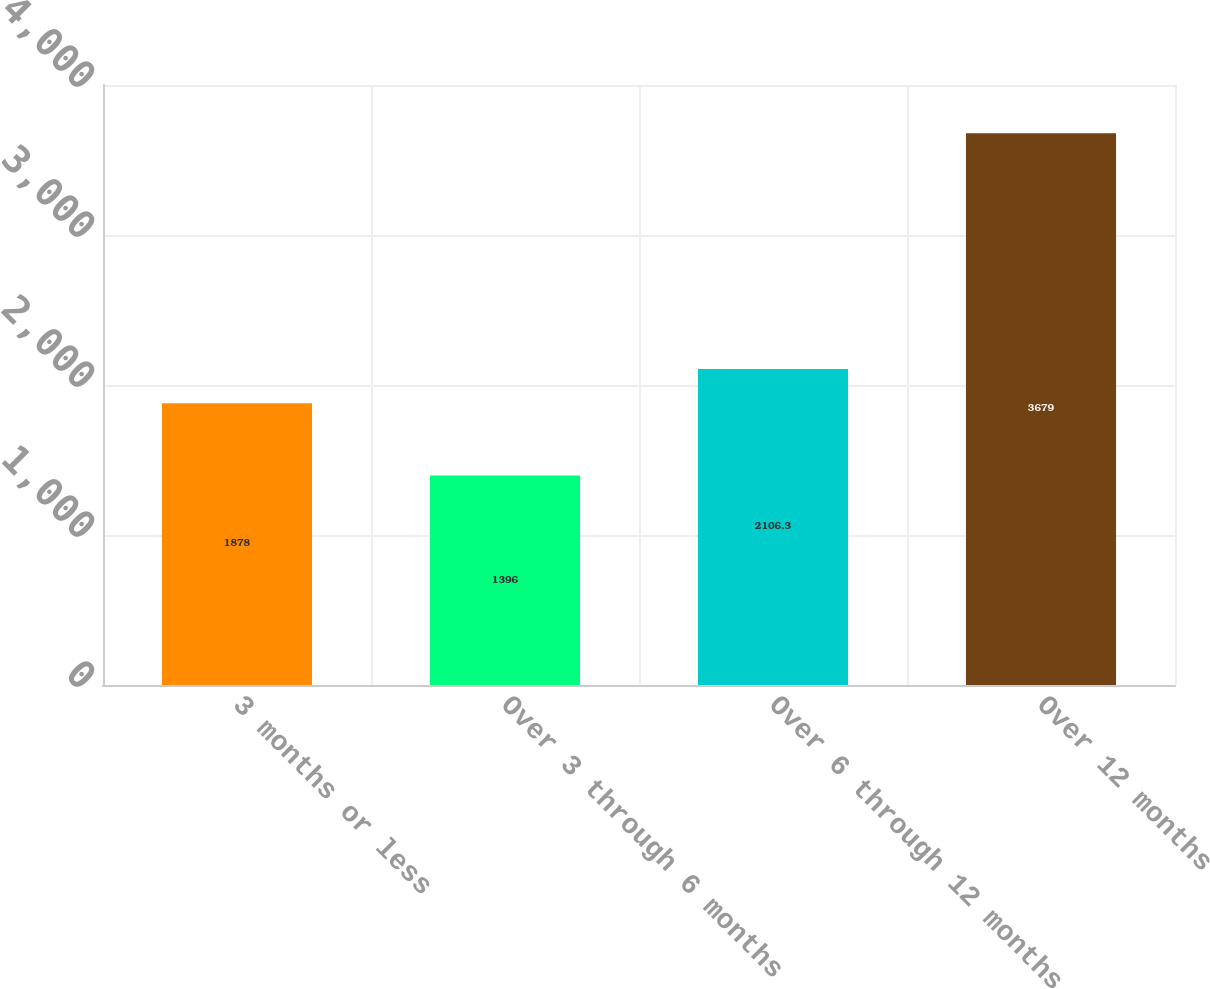Convert chart to OTSL. <chart><loc_0><loc_0><loc_500><loc_500><bar_chart><fcel>3 months or less<fcel>Over 3 through 6 months<fcel>Over 6 through 12 months<fcel>Over 12 months<nl><fcel>1878<fcel>1396<fcel>2106.3<fcel>3679<nl></chart> 